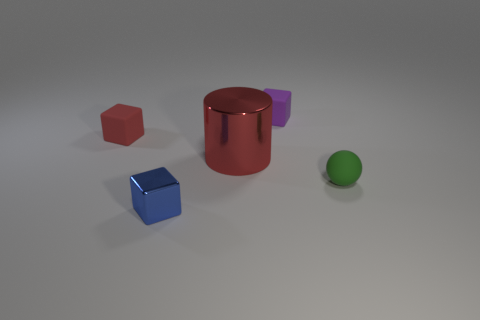Are there any other things that are the same size as the cylinder?
Keep it short and to the point. No. Is the number of tiny things behind the purple object greater than the number of cylinders that are to the right of the big red cylinder?
Your answer should be very brief. No. Is the color of the metal thing left of the big red metallic thing the same as the matte block to the left of the big red object?
Give a very brief answer. No. The green rubber object that is the same size as the blue cube is what shape?
Offer a very short reply. Sphere. Is there another small purple shiny thing of the same shape as the small purple object?
Your answer should be compact. No. Is the material of the small thing that is in front of the tiny green rubber sphere the same as the object that is behind the red matte cube?
Provide a succinct answer. No. The tiny thing that is the same color as the metallic cylinder is what shape?
Your answer should be compact. Cube. What number of small red things have the same material as the tiny ball?
Your answer should be very brief. 1. The big metal cylinder has what color?
Your response must be concise. Red. There is a tiny object that is in front of the green matte object; is its shape the same as the red object that is behind the red cylinder?
Make the answer very short. Yes. 